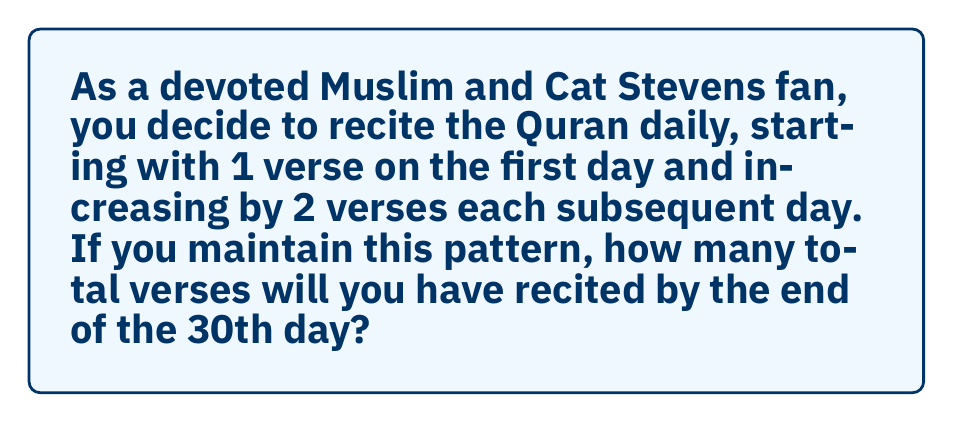Show me your answer to this math problem. Let's approach this step-by-step using the arithmetic series formula:

1) First, identify the components of the arithmetic series:
   - $a_1 = 1$ (first term: 1 verse on day 1)
   - $d = 2$ (common difference: increase by 2 verses each day)
   - $n = 30$ (number of terms: 30 days)

2) The last term of the series, $a_n$, can be calculated using:
   $a_n = a_1 + (n-1)d$
   $a_{30} = 1 + (30-1)2 = 1 + 58 = 59$

3) For an arithmetic series, the partial sum formula is:
   $S_n = \frac{n}{2}(a_1 + a_n)$

4) Substituting our values:
   $S_{30} = \frac{30}{2}(1 + 59)$

5) Simplify:
   $S_{30} = 15(60) = 900$

Therefore, by the end of the 30th day, you will have recited a total of 900 verses.
Answer: 900 verses 